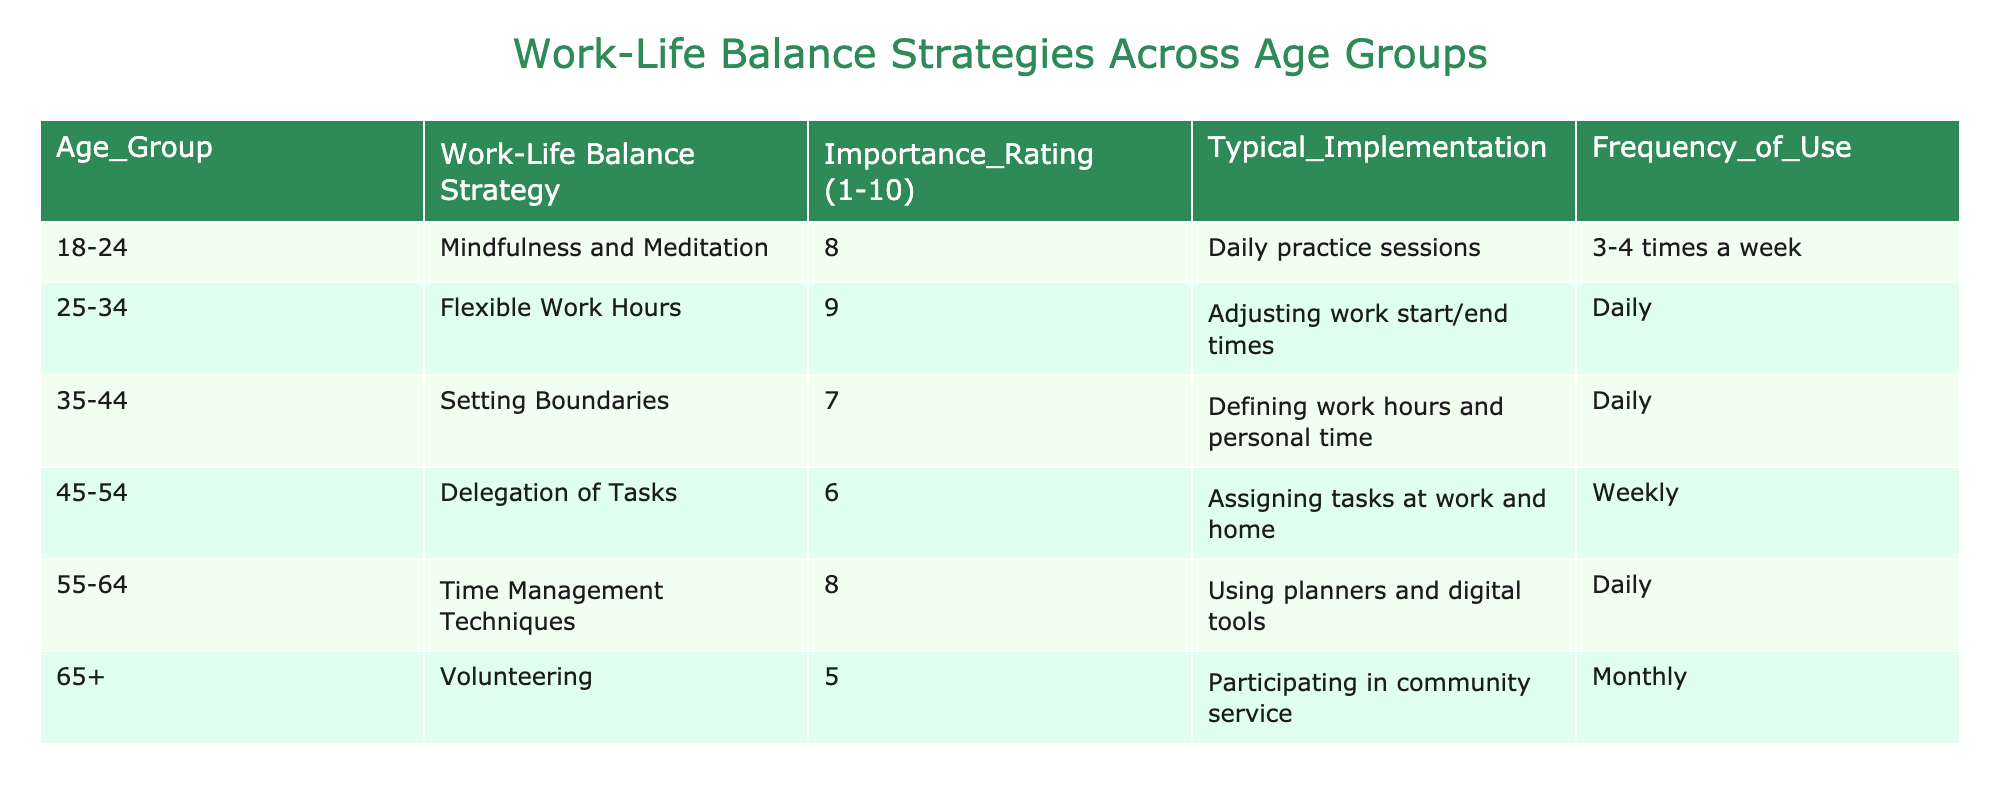What is the importance rating for Flexible Work Hours? The table lists Flexible Work Hours under the age group 25-34 with an Importance Rating of 9.
Answer: 9 Which age group has the highest frequency of use for their strategy? Looking at the Frequency of Use column, the age group 25-34 using Flexible Work Hours is marked as Daily, more often than any other strategy listed.
Answer: 25-34 What is the average importance rating across all age groups? The importance ratings are 8, 9, 7, 6, 8, and 5. Summing these gives 43, and dividing by the number of age groups (6) gives an average of 43/6 = 7.17.
Answer: 7.17 Is Volunteering considered a highly rated strategy for Work-Life Balance? The Importance Rating for Volunteering under the age group 65+ is 5, which indicates that it is not highly valued compared to other strategies.
Answer: No Which age group implements time management techniques most frequently? According to the table, the age group 55-64 uses Time Management Techniques Daily, which is the highest frequency listed.
Answer: 55-64 What is the difference in the importance rating between the age groups 25-34 and 35-44? The importance rating for 25-34 is 9, while for 35-44 it is 7. The difference is 9 - 7 = 2.
Answer: 2 Do any age groups list Delegation of Tasks as a primary strategy? The age group 45-54 lists Delegation of Tasks but with a lower Importance Rating of 6, indicating it is not viewed as a primary strategy.
Answer: No Which two age groups have similar importance ratings, and what is their rating? The age groups 35-44 and 45-54 have close Importance Ratings of 7 and 6 respectively, indicating similar but lower importance than others.
Answer: 7 and 6 